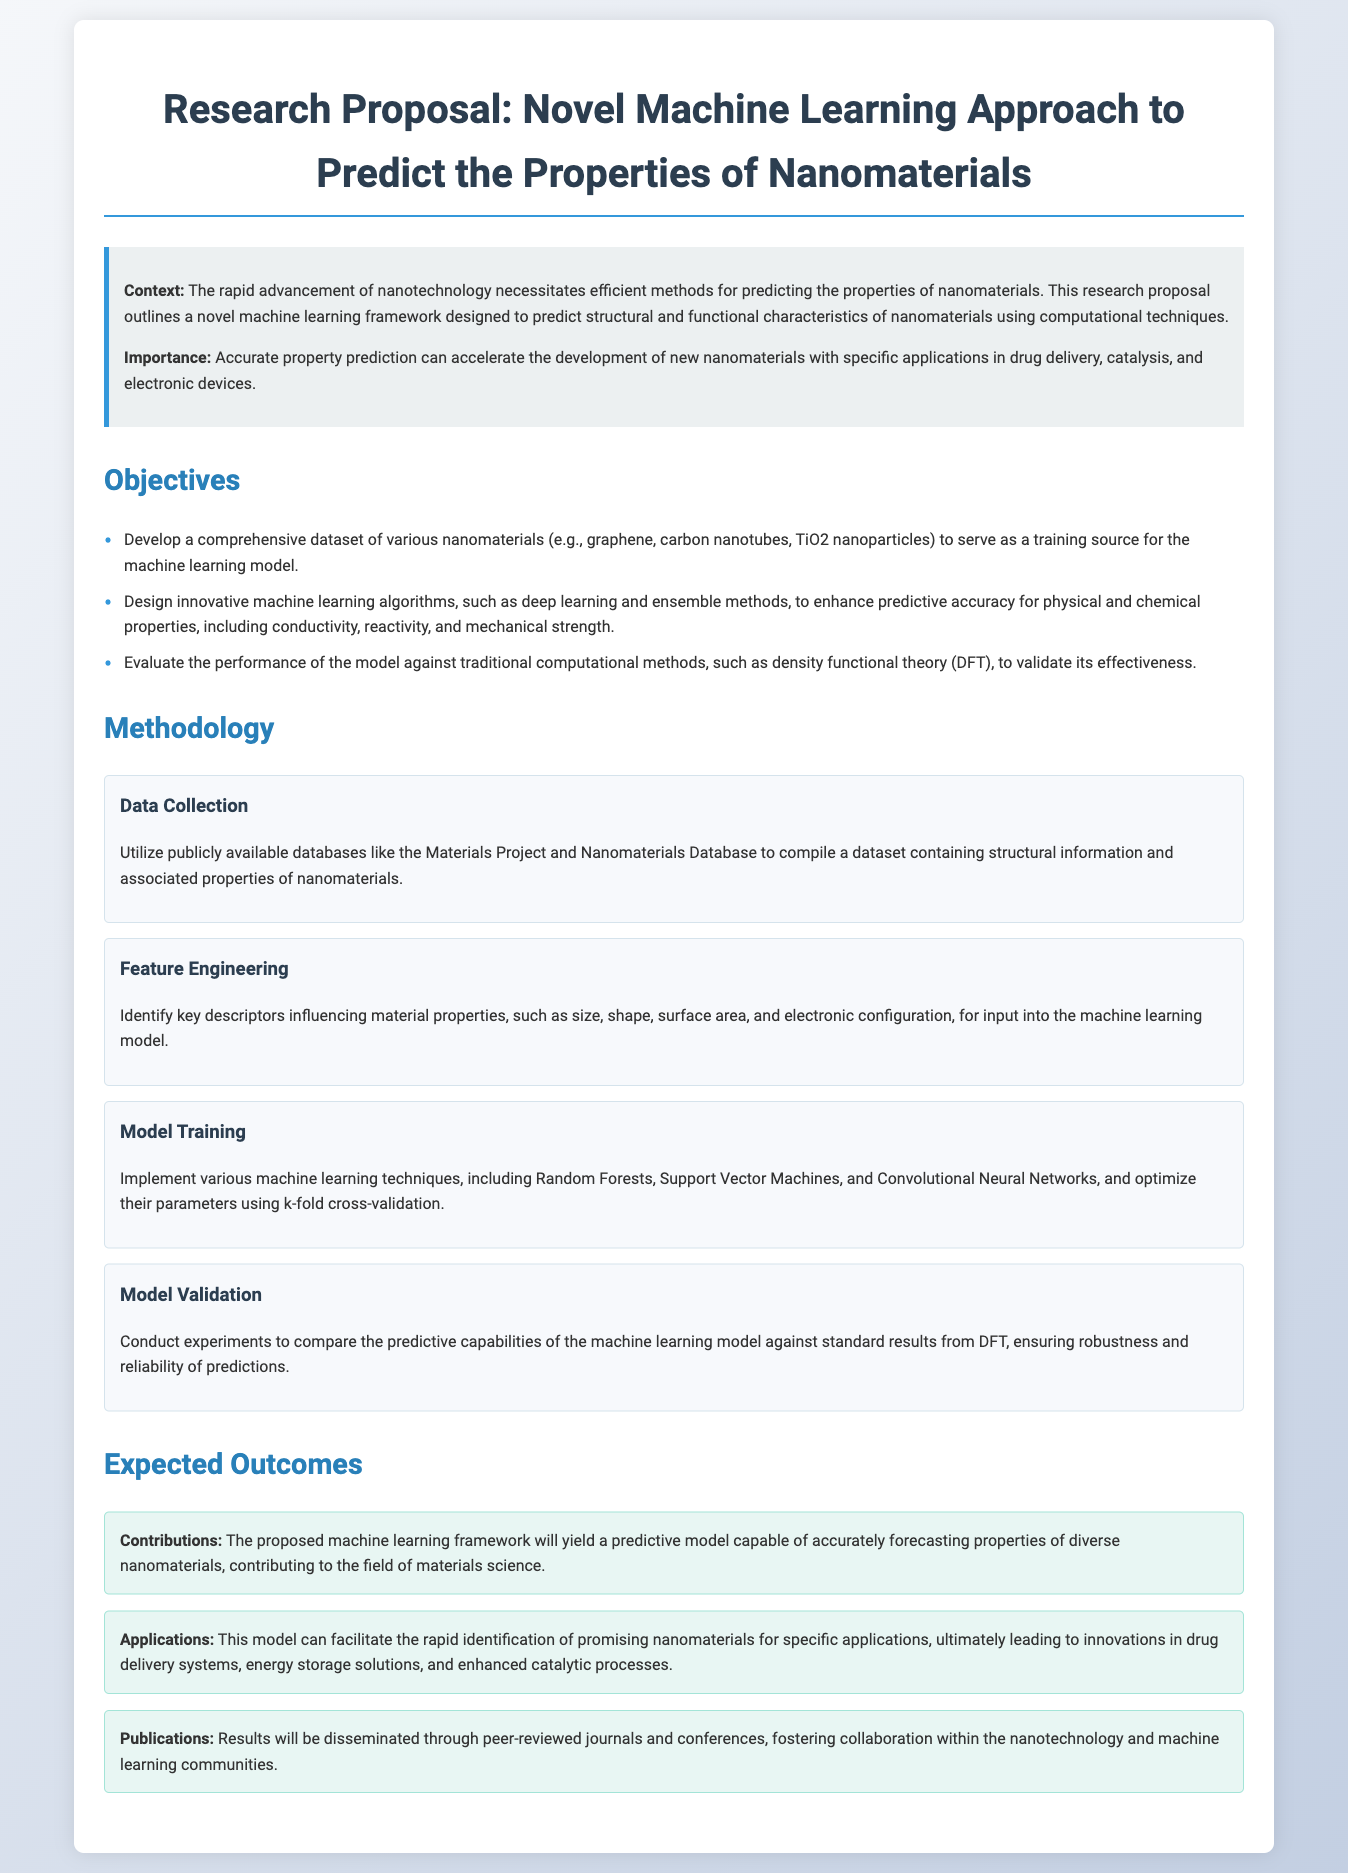What is the title of the proposal? The title of the proposal is mentioned prominently at the beginning of the document.
Answer: Research Proposal: Novel Machine Learning Approach to Predict the Properties of Nanomaterials What is one application of the proposed model? The document lists applications of the model under expected outcomes, highlighting its practical uses.
Answer: Drug delivery systems Which machine learning technique is used for model training? Various techniques are mentioned in the methodology section, specifically for training the model.
Answer: Random Forests How many objectives are outlined in the proposal? The objectives section lists several goals, and counting them reveals the total.
Answer: Three What is one expected outcome related to publications? The expected outcomes section describes how the results will be shared, including venues for dissemination.
Answer: Peer-reviewed journals Which database is mentioned for data collection? The methodology section specifies sources of data for collecting information on nanomaterials.
Answer: Materials Project What type of algorithms are being developed? The objectives section describes the focus on certain kinds of algorithms to improve prediction accuracy.
Answer: Machine learning algorithms What is one descriptor influencing material properties? The methodology section mentions several key descriptors that affect material properties.
Answer: Size 